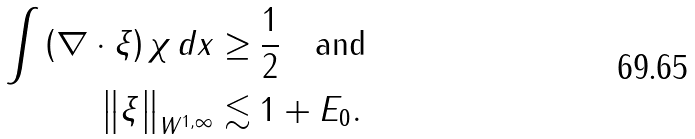Convert formula to latex. <formula><loc_0><loc_0><loc_500><loc_500>\int \left ( \nabla \cdot \xi \right ) \chi \, d x & \geq \frac { 1 } { 2 } \quad \text {and} \\ \left \| \xi \right \| _ { W ^ { 1 , \infty } } & \lesssim 1 + E _ { 0 } .</formula> 